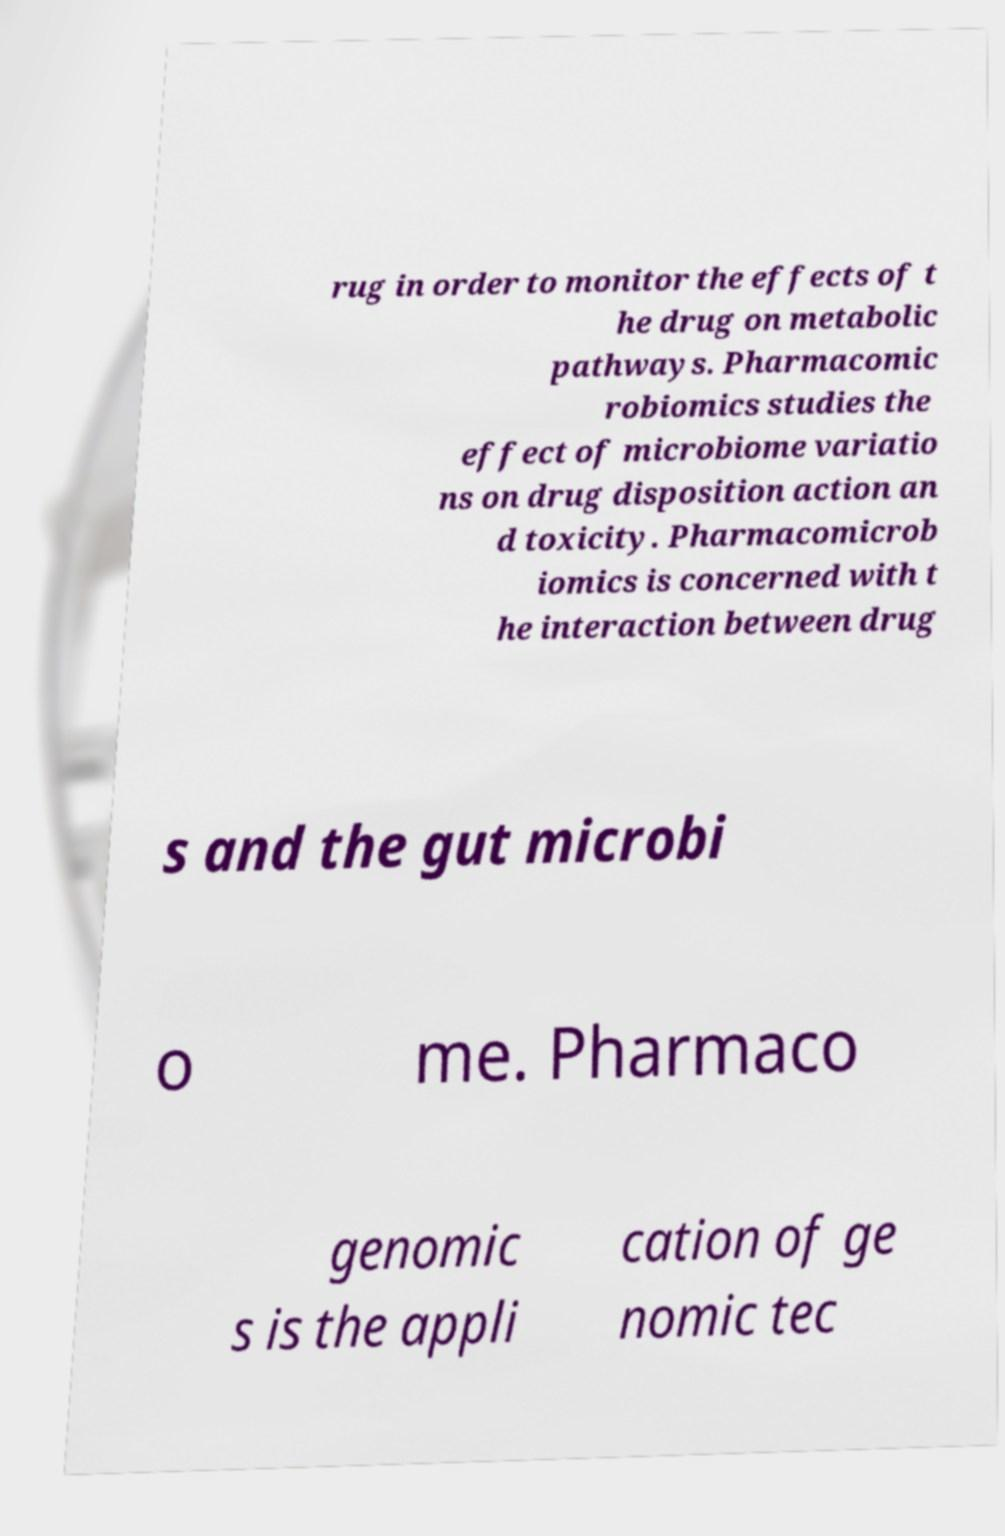I need the written content from this picture converted into text. Can you do that? rug in order to monitor the effects of t he drug on metabolic pathways. Pharmacomic robiomics studies the effect of microbiome variatio ns on drug disposition action an d toxicity. Pharmacomicrob iomics is concerned with t he interaction between drug s and the gut microbi o me. Pharmaco genomic s is the appli cation of ge nomic tec 